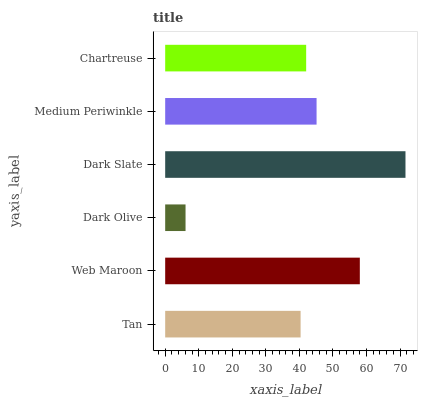Is Dark Olive the minimum?
Answer yes or no. Yes. Is Dark Slate the maximum?
Answer yes or no. Yes. Is Web Maroon the minimum?
Answer yes or no. No. Is Web Maroon the maximum?
Answer yes or no. No. Is Web Maroon greater than Tan?
Answer yes or no. Yes. Is Tan less than Web Maroon?
Answer yes or no. Yes. Is Tan greater than Web Maroon?
Answer yes or no. No. Is Web Maroon less than Tan?
Answer yes or no. No. Is Medium Periwinkle the high median?
Answer yes or no. Yes. Is Chartreuse the low median?
Answer yes or no. Yes. Is Chartreuse the high median?
Answer yes or no. No. Is Web Maroon the low median?
Answer yes or no. No. 